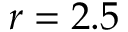Convert formula to latex. <formula><loc_0><loc_0><loc_500><loc_500>r = 2 . 5</formula> 